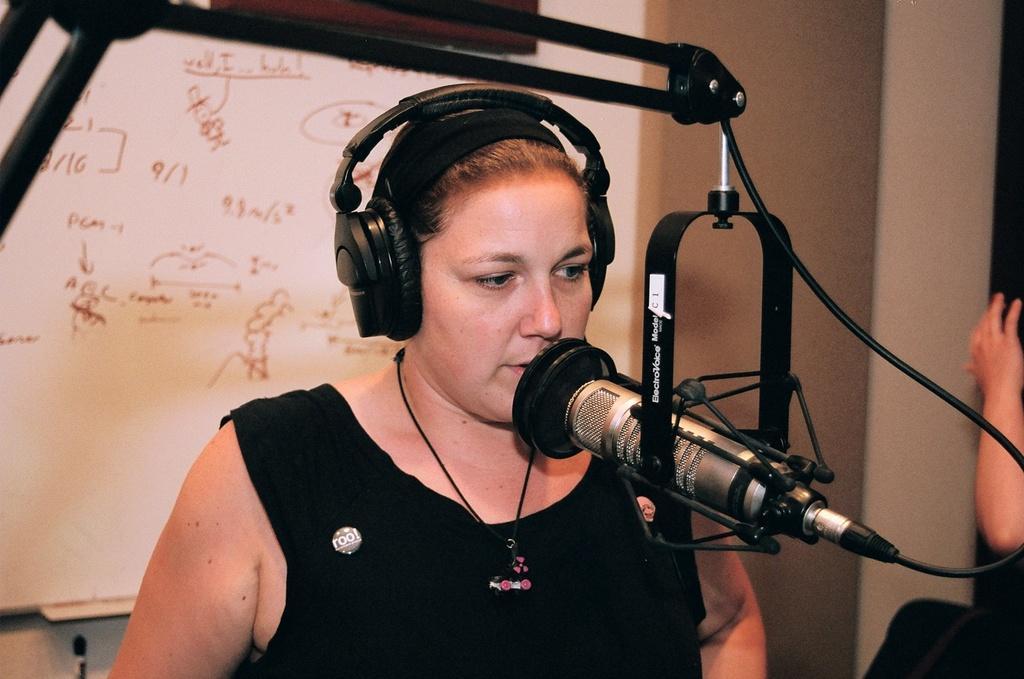How would you summarize this image in a sentence or two? In this image I can see a woman wearing black colored dress and a microphone which is silver and black in color in front of her. I can see she is wearing black colored headphones. In the background I can see the wall, a person's hand and the white colored board. 